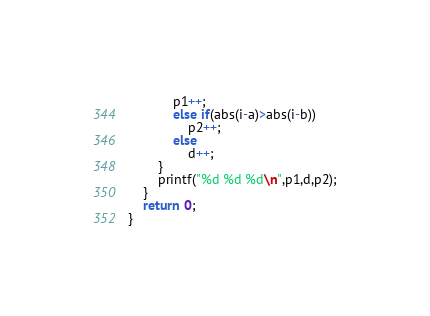Convert code to text. <code><loc_0><loc_0><loc_500><loc_500><_C++_>            p1++;
            else if(abs(i-a)>abs(i-b))
                p2++;
            else
                d++;
        }
        printf("%d %d %d\n",p1,d,p2);
    }
    return 0;
}
</code> 